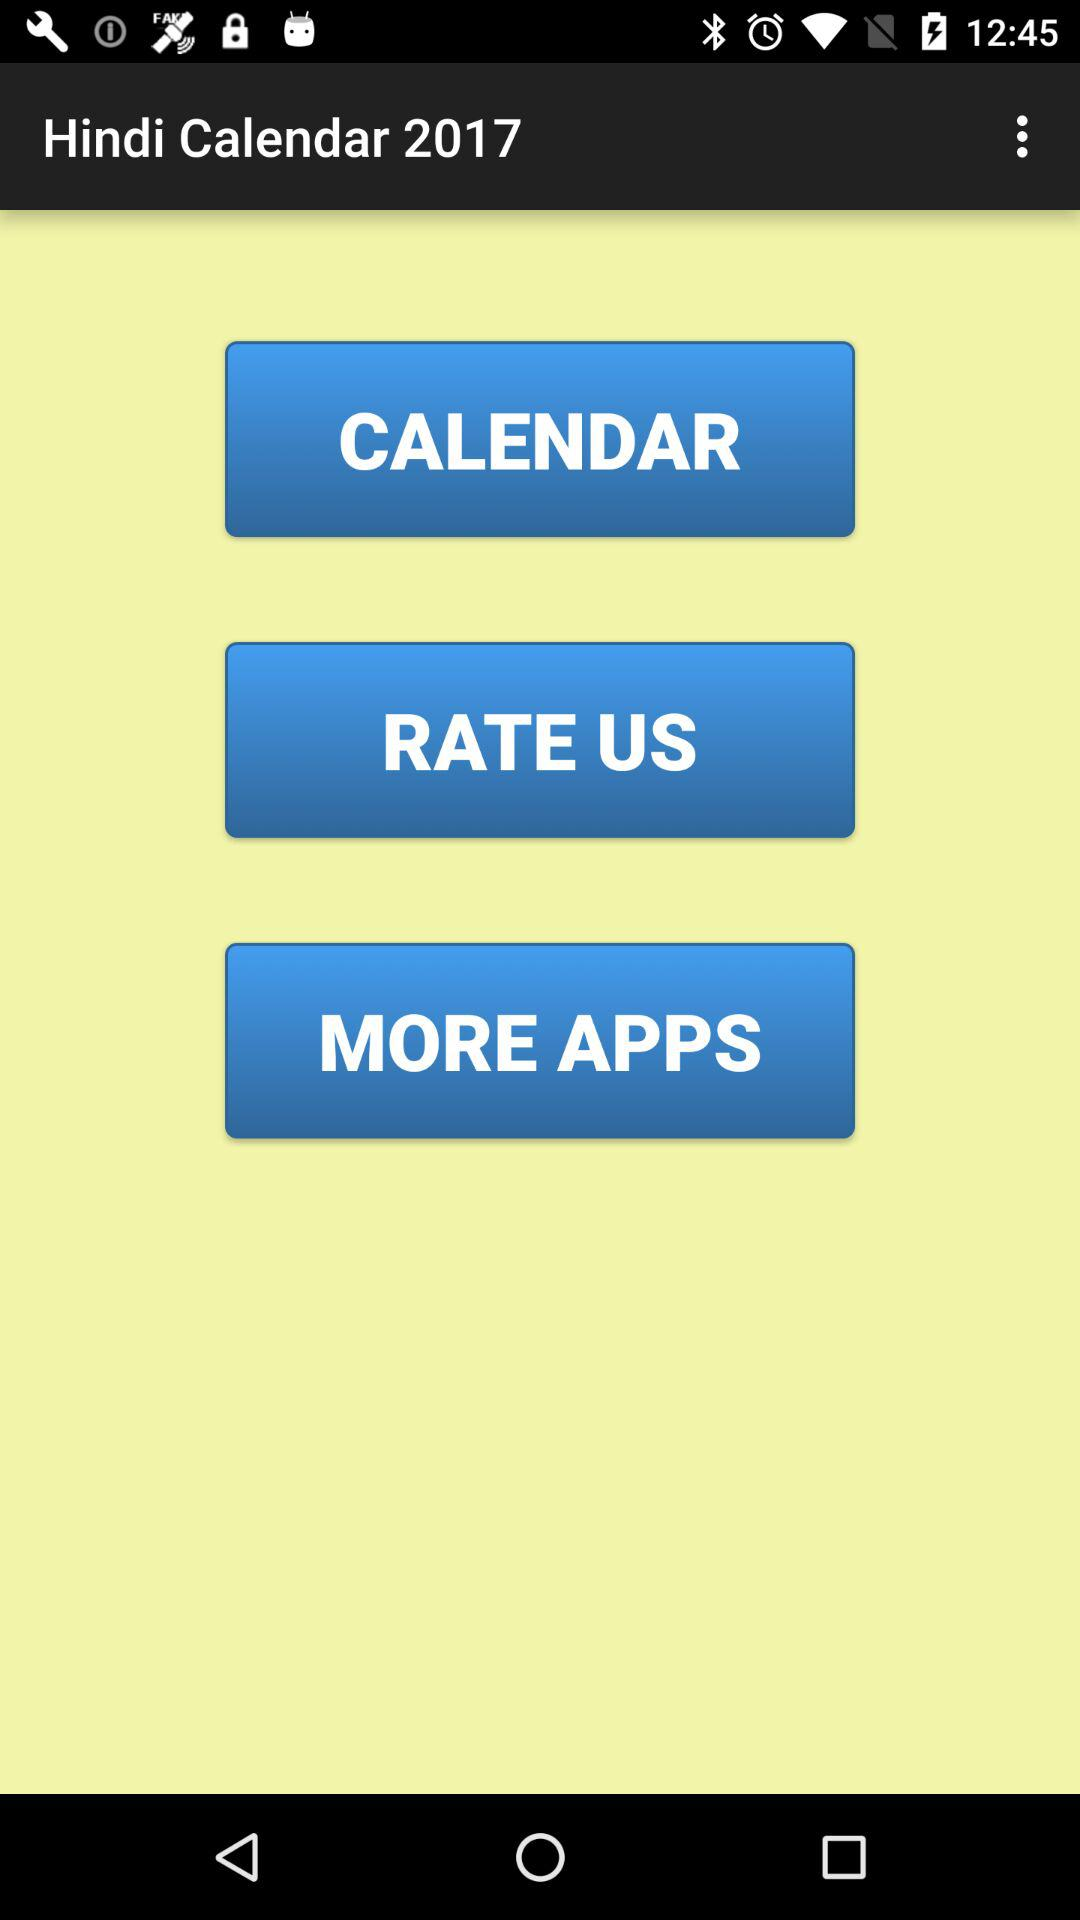What is the application name? The application name is "Hindi Calendar 2017". 